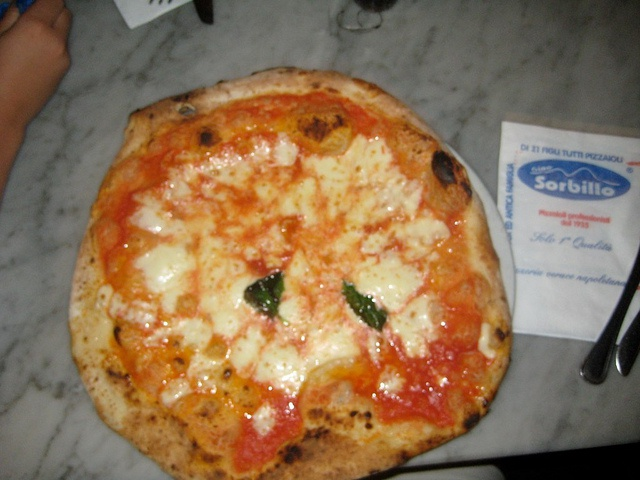Describe the objects in this image and their specific colors. I can see pizza in black, red, tan, and orange tones, people in black, brown, maroon, and gray tones, fork in black, darkgray, and gray tones, and knife in black and gray tones in this image. 